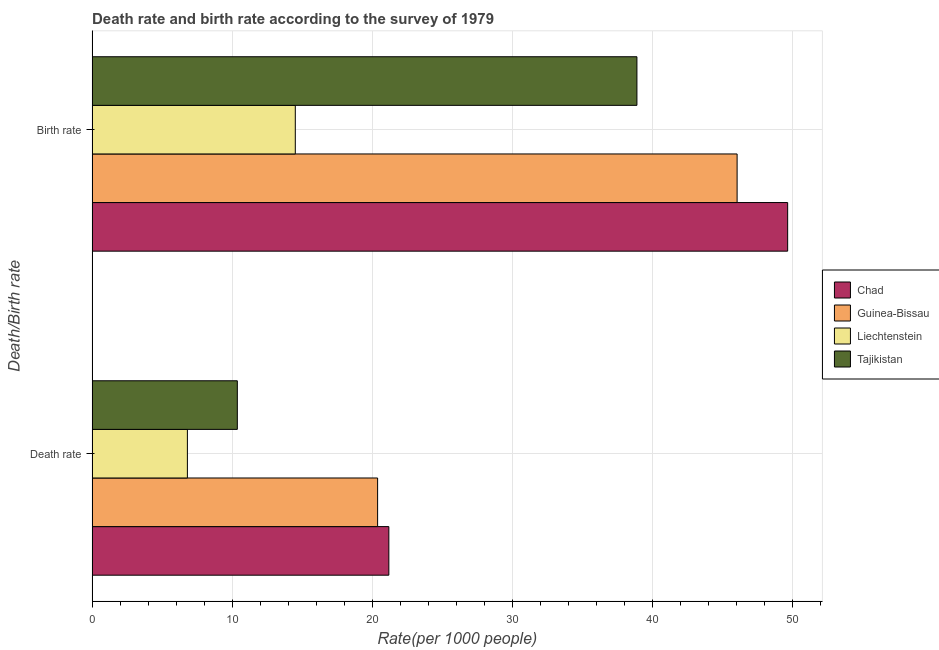Are the number of bars per tick equal to the number of legend labels?
Provide a succinct answer. Yes. How many bars are there on the 1st tick from the bottom?
Provide a short and direct response. 4. What is the label of the 1st group of bars from the top?
Provide a short and direct response. Birth rate. What is the death rate in Guinea-Bissau?
Make the answer very short. 20.37. Across all countries, what is the maximum birth rate?
Make the answer very short. 49.63. Across all countries, what is the minimum death rate?
Ensure brevity in your answer.  6.8. In which country was the birth rate maximum?
Keep it short and to the point. Chad. In which country was the death rate minimum?
Make the answer very short. Liechtenstein. What is the total death rate in the graph?
Your response must be concise. 58.71. What is the difference between the birth rate in Liechtenstein and that in Guinea-Bissau?
Your answer should be very brief. -31.53. What is the difference between the death rate in Tajikistan and the birth rate in Chad?
Offer a terse response. -39.27. What is the average death rate per country?
Offer a very short reply. 14.68. What is the difference between the death rate and birth rate in Guinea-Bissau?
Your answer should be very brief. -25.65. In how many countries, is the birth rate greater than 20 ?
Provide a short and direct response. 3. What is the ratio of the birth rate in Tajikistan to that in Liechtenstein?
Offer a terse response. 2.68. Is the birth rate in Tajikistan less than that in Chad?
Offer a terse response. Yes. What does the 2nd bar from the top in Birth rate represents?
Offer a terse response. Liechtenstein. What does the 1st bar from the bottom in Birth rate represents?
Offer a terse response. Chad. How many countries are there in the graph?
Offer a terse response. 4. Where does the legend appear in the graph?
Offer a very short reply. Center right. How are the legend labels stacked?
Ensure brevity in your answer.  Vertical. What is the title of the graph?
Your answer should be compact. Death rate and birth rate according to the survey of 1979. Does "Vanuatu" appear as one of the legend labels in the graph?
Your answer should be compact. No. What is the label or title of the X-axis?
Give a very brief answer. Rate(per 1000 people). What is the label or title of the Y-axis?
Your answer should be compact. Death/Birth rate. What is the Rate(per 1000 people) in Chad in Death rate?
Offer a very short reply. 21.18. What is the Rate(per 1000 people) of Guinea-Bissau in Death rate?
Offer a very short reply. 20.37. What is the Rate(per 1000 people) of Liechtenstein in Death rate?
Offer a very short reply. 6.8. What is the Rate(per 1000 people) in Tajikistan in Death rate?
Ensure brevity in your answer.  10.36. What is the Rate(per 1000 people) in Chad in Birth rate?
Ensure brevity in your answer.  49.63. What is the Rate(per 1000 people) in Guinea-Bissau in Birth rate?
Keep it short and to the point. 46.03. What is the Rate(per 1000 people) of Liechtenstein in Birth rate?
Offer a very short reply. 14.5. What is the Rate(per 1000 people) in Tajikistan in Birth rate?
Your response must be concise. 38.88. Across all Death/Birth rate, what is the maximum Rate(per 1000 people) in Chad?
Provide a succinct answer. 49.63. Across all Death/Birth rate, what is the maximum Rate(per 1000 people) of Guinea-Bissau?
Keep it short and to the point. 46.03. Across all Death/Birth rate, what is the maximum Rate(per 1000 people) in Tajikistan?
Give a very brief answer. 38.88. Across all Death/Birth rate, what is the minimum Rate(per 1000 people) of Chad?
Make the answer very short. 21.18. Across all Death/Birth rate, what is the minimum Rate(per 1000 people) in Guinea-Bissau?
Ensure brevity in your answer.  20.37. Across all Death/Birth rate, what is the minimum Rate(per 1000 people) in Tajikistan?
Provide a succinct answer. 10.36. What is the total Rate(per 1000 people) of Chad in the graph?
Give a very brief answer. 70.81. What is the total Rate(per 1000 people) in Guinea-Bissau in the graph?
Your answer should be compact. 66.4. What is the total Rate(per 1000 people) in Liechtenstein in the graph?
Your answer should be very brief. 21.3. What is the total Rate(per 1000 people) in Tajikistan in the graph?
Your answer should be compact. 49.24. What is the difference between the Rate(per 1000 people) in Chad in Death rate and that in Birth rate?
Ensure brevity in your answer.  -28.46. What is the difference between the Rate(per 1000 people) in Guinea-Bissau in Death rate and that in Birth rate?
Your answer should be very brief. -25.65. What is the difference between the Rate(per 1000 people) of Tajikistan in Death rate and that in Birth rate?
Offer a very short reply. -28.51. What is the difference between the Rate(per 1000 people) of Chad in Death rate and the Rate(per 1000 people) of Guinea-Bissau in Birth rate?
Make the answer very short. -24.85. What is the difference between the Rate(per 1000 people) in Chad in Death rate and the Rate(per 1000 people) in Liechtenstein in Birth rate?
Provide a short and direct response. 6.67. What is the difference between the Rate(per 1000 people) of Chad in Death rate and the Rate(per 1000 people) of Tajikistan in Birth rate?
Ensure brevity in your answer.  -17.7. What is the difference between the Rate(per 1000 people) in Guinea-Bissau in Death rate and the Rate(per 1000 people) in Liechtenstein in Birth rate?
Keep it short and to the point. 5.87. What is the difference between the Rate(per 1000 people) in Guinea-Bissau in Death rate and the Rate(per 1000 people) in Tajikistan in Birth rate?
Your answer should be very brief. -18.5. What is the difference between the Rate(per 1000 people) of Liechtenstein in Death rate and the Rate(per 1000 people) of Tajikistan in Birth rate?
Keep it short and to the point. -32.08. What is the average Rate(per 1000 people) of Chad per Death/Birth rate?
Keep it short and to the point. 35.4. What is the average Rate(per 1000 people) in Guinea-Bissau per Death/Birth rate?
Provide a short and direct response. 33.2. What is the average Rate(per 1000 people) of Liechtenstein per Death/Birth rate?
Provide a short and direct response. 10.65. What is the average Rate(per 1000 people) in Tajikistan per Death/Birth rate?
Ensure brevity in your answer.  24.62. What is the difference between the Rate(per 1000 people) of Chad and Rate(per 1000 people) of Guinea-Bissau in Death rate?
Provide a short and direct response. 0.8. What is the difference between the Rate(per 1000 people) of Chad and Rate(per 1000 people) of Liechtenstein in Death rate?
Offer a terse response. 14.38. What is the difference between the Rate(per 1000 people) of Chad and Rate(per 1000 people) of Tajikistan in Death rate?
Ensure brevity in your answer.  10.81. What is the difference between the Rate(per 1000 people) of Guinea-Bissau and Rate(per 1000 people) of Liechtenstein in Death rate?
Offer a terse response. 13.57. What is the difference between the Rate(per 1000 people) of Guinea-Bissau and Rate(per 1000 people) of Tajikistan in Death rate?
Give a very brief answer. 10.01. What is the difference between the Rate(per 1000 people) in Liechtenstein and Rate(per 1000 people) in Tajikistan in Death rate?
Your answer should be compact. -3.56. What is the difference between the Rate(per 1000 people) of Chad and Rate(per 1000 people) of Guinea-Bissau in Birth rate?
Your response must be concise. 3.61. What is the difference between the Rate(per 1000 people) of Chad and Rate(per 1000 people) of Liechtenstein in Birth rate?
Your answer should be very brief. 35.13. What is the difference between the Rate(per 1000 people) of Chad and Rate(per 1000 people) of Tajikistan in Birth rate?
Your answer should be very brief. 10.76. What is the difference between the Rate(per 1000 people) in Guinea-Bissau and Rate(per 1000 people) in Liechtenstein in Birth rate?
Make the answer very short. 31.53. What is the difference between the Rate(per 1000 people) in Guinea-Bissau and Rate(per 1000 people) in Tajikistan in Birth rate?
Ensure brevity in your answer.  7.15. What is the difference between the Rate(per 1000 people) in Liechtenstein and Rate(per 1000 people) in Tajikistan in Birth rate?
Ensure brevity in your answer.  -24.38. What is the ratio of the Rate(per 1000 people) in Chad in Death rate to that in Birth rate?
Provide a short and direct response. 0.43. What is the ratio of the Rate(per 1000 people) in Guinea-Bissau in Death rate to that in Birth rate?
Make the answer very short. 0.44. What is the ratio of the Rate(per 1000 people) of Liechtenstein in Death rate to that in Birth rate?
Offer a very short reply. 0.47. What is the ratio of the Rate(per 1000 people) in Tajikistan in Death rate to that in Birth rate?
Make the answer very short. 0.27. What is the difference between the highest and the second highest Rate(per 1000 people) of Chad?
Offer a very short reply. 28.46. What is the difference between the highest and the second highest Rate(per 1000 people) of Guinea-Bissau?
Your response must be concise. 25.65. What is the difference between the highest and the second highest Rate(per 1000 people) in Tajikistan?
Your response must be concise. 28.51. What is the difference between the highest and the lowest Rate(per 1000 people) of Chad?
Offer a terse response. 28.46. What is the difference between the highest and the lowest Rate(per 1000 people) in Guinea-Bissau?
Provide a short and direct response. 25.65. What is the difference between the highest and the lowest Rate(per 1000 people) in Liechtenstein?
Provide a short and direct response. 7.7. What is the difference between the highest and the lowest Rate(per 1000 people) of Tajikistan?
Keep it short and to the point. 28.51. 